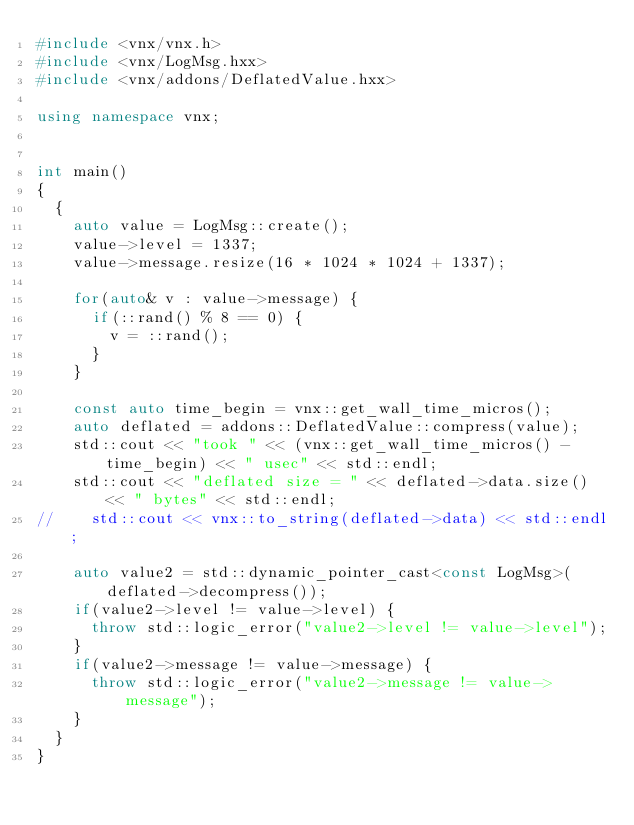Convert code to text. <code><loc_0><loc_0><loc_500><loc_500><_C++_>#include <vnx/vnx.h>
#include <vnx/LogMsg.hxx>
#include <vnx/addons/DeflatedValue.hxx>

using namespace vnx;


int main()
{
	{
		auto value = LogMsg::create();
		value->level = 1337;
		value->message.resize(16 * 1024 * 1024 + 1337);
		
		for(auto& v : value->message) {
			if(::rand() % 8 == 0) {
				v = ::rand();
			}
		}

		const auto time_begin = vnx::get_wall_time_micros();
		auto deflated = addons::DeflatedValue::compress(value);
		std::cout << "took " << (vnx::get_wall_time_micros() - time_begin) << " usec" << std::endl;
		std::cout << "deflated size = " << deflated->data.size() << " bytes" << std::endl;
//		std::cout << vnx::to_string(deflated->data) << std::endl;
		
		auto value2 = std::dynamic_pointer_cast<const LogMsg>(deflated->decompress());
		if(value2->level != value->level) {
			throw std::logic_error("value2->level != value->level");
		}
		if(value2->message != value->message) {
			throw std::logic_error("value2->message != value->message");
		}
	}
}

</code> 